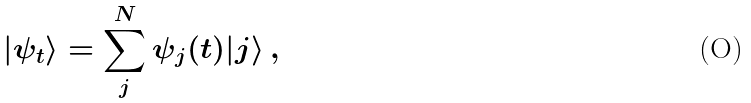<formula> <loc_0><loc_0><loc_500><loc_500>| \psi _ { t } \rangle = \sum _ { j } ^ { N } \psi _ { j } ( t ) | j \rangle \, ,</formula> 